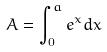<formula> <loc_0><loc_0><loc_500><loc_500>A = \int _ { 0 } ^ { a } e ^ { x } d x</formula> 